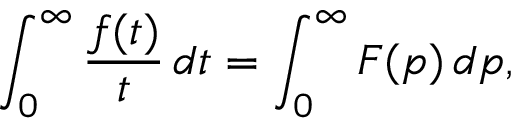Convert formula to latex. <formula><loc_0><loc_0><loc_500><loc_500>\int _ { 0 } ^ { \infty } { \frac { f ( t ) } { t } } \, d t = \int _ { 0 } ^ { \infty } F ( p ) \, d p ,</formula> 